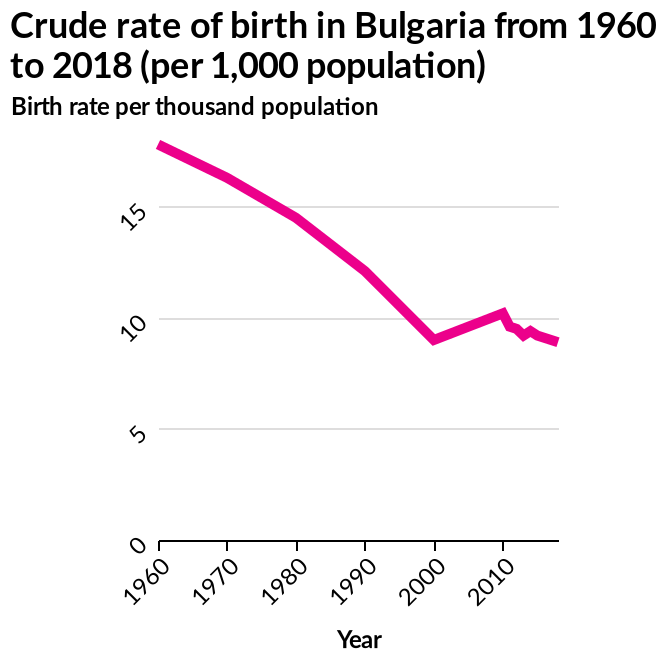<image>
What is the time period covered by the line diagram? The line diagram covers the time period from 1960 to 2018. Describe the following image in detail Here a is a line diagram named Crude rate of birth in Bulgaria from 1960 to 2018 (per 1,000 population). There is a linear scale from 1960 to 2010 on the x-axis, marked Year. The y-axis plots Birth rate per thousand population on a linear scale from 0 to 15. Is there a line diagram named Crude rate of birth in Bulgaria from 2018 to 1960 (per 1,000 population)? No.Here a is a line diagram named Crude rate of birth in Bulgaria from 1960 to 2018 (per 1,000 population). There is a linear scale from 1960 to 2010 on the x-axis, marked Year. The y-axis plots Birth rate per thousand population on a linear scale from 0 to 15. 